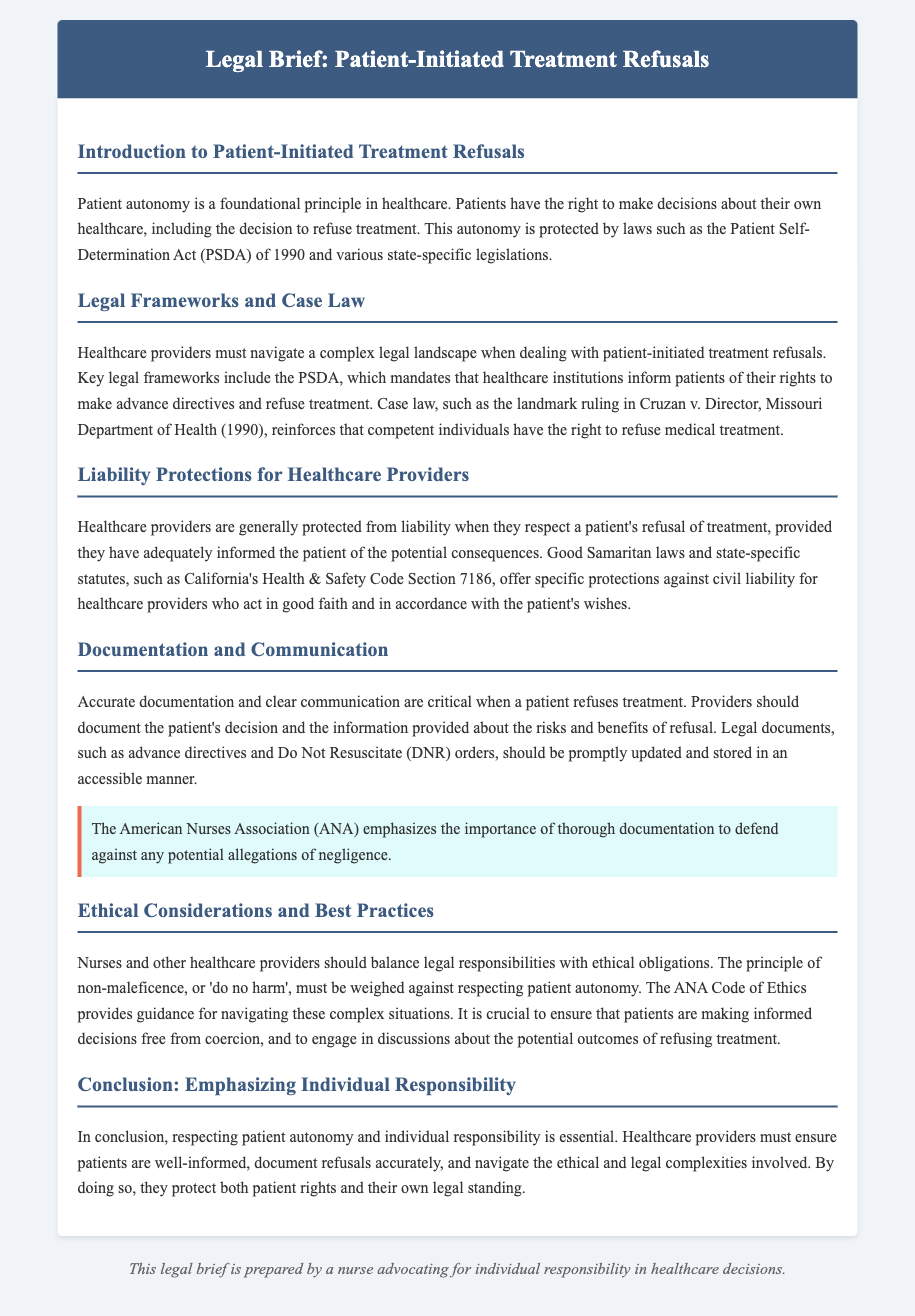What is the foundational principle in healthcare? The foundational principle in healthcare, as stated in the document, is patient autonomy.
Answer: Patient autonomy What act was established in 1990 to protect patient rights? The document mentions the Patient Self-Determination Act (PSDA) established in 1990.
Answer: Patient Self-Determination Act (PSDA) Which landmark case affirmed the right to refuse medical treatment? The document references the case Cruzan v. Director, Missouri Department of Health (1990) that affirmed this right.
Answer: Cruzan v. Director, Missouri Department of Health What does the American Nurses Association emphasize about documentation? The document states that the ANA emphasizes the importance of thorough documentation to defend against allegations of negligence.
Answer: Thorough documentation What should healthcare providers do when a patient refuses treatment? The document highlights that providers should document the patient's decision and the information provided about the risks and benefits of refusal.
Answer: Document the decision and information What ethical principle must be balanced with patient autonomy? The document indicates that the principle of non-maleficence must be weighed against respecting patient autonomy.
Answer: Non-maleficence Which code provides guidance for navigating complex patient decisions? The document mentions the ANA Code of Ethics as guidance for these situations.
Answer: ANA Code of Ethics What is emphasized in the conclusion regarding healthcare decisions? The conclusion emphasizes that individual responsibility is essential in healthcare decisions.
Answer: Individual responsibility 